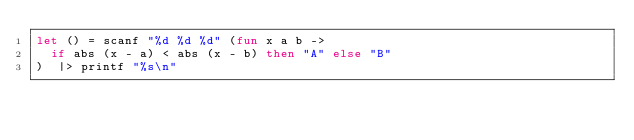Convert code to text. <code><loc_0><loc_0><loc_500><loc_500><_OCaml_>let () = scanf "%d %d %d" (fun x a b ->
  if abs (x - a) < abs (x - b) then "A" else "B"
)  |> printf "%s\n"</code> 